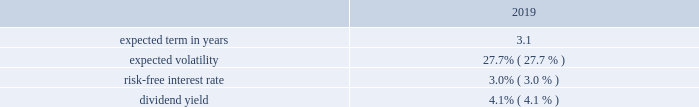Westrock company notes to consolidated financial statements 2014 ( continued ) our results of operations for the fiscal years ended september 30 , 2019 , 2018 and 2017 include share-based compensation expense of $ 64.2 million , $ 66.8 million and $ 60.9 million , respectively , including $ 2.9 million included in the gain on sale of hh&b in fiscal 2017 .
Share-based compensation expense in fiscal 2017 was reduced by $ 5.4 million for the rescission of shares granted to our ceo that were inadvertently granted in excess of plan limits in fiscal 2014 and 2015 .
The total income tax benefit in the results of operations in connection with share-based compensation was $ 16.3 million , $ 19.4 million and $ 22.5 million , for the fiscal years ended september 30 , 2019 , 2018 and 2017 , respectively .
Cash received from share-based payment arrangements for the fiscal years ended september 30 , 2019 , 2018 and 2017 was $ 61.5 million , $ 44.4 million and $ 59.2 million , respectively .
Equity awards issued in connection with acquisitions in connection with the kapstone acquisition , we replaced certain outstanding awards of restricted stock units granted under the kapstone long-term incentive plan with westrock stock options and restricted stock units .
No additional shares will be granted under the kapstone plan .
The kapstone equity awards were replaced with awards with identical terms utilizing an approximately 0.83 conversion factor as described in the merger agreement .
The acquisition consideration included approximately $ 70.8 million related to outstanding kapstone equity awards related to service prior to the effective date of the kapstone acquisition 2013 the balance related to service after the effective date will be expensed over the remaining service period of the awards .
As part of the kapstone acquisition , we issued 2665462 options that were valued at a weighted average fair value of $ 20.99 per share using the black-scholes option pricing model .
The weighted average significant assumptions used were: .
In connection with the mps acquisition , we replaced certain outstanding awards of restricted stock units granted under the mps long-term incentive plan with westrock restricted stock units .
No additional shares will be granted under the mps plan .
The mps equity awards were replaced with identical terms utilizing an approximately 0.33 conversion factor as described in the merger agreement .
As part of the mps acquisition , we granted 119373 awards of restricted stock units , which contain service conditions and were valued at $ 54.24 per share .
The acquisition consideration included approximately $ 1.9 million related to outstanding mps equity awards related to service prior to the effective date of the mps acquisition 2013 the balance related to service after the effective date will be expensed over the remaining service period of the awards .
Stock options and stock appreciation rights stock options granted under our plans generally have an exercise price equal to the closing market price on the date of the grant , generally vest in three years , in either one tranche or in approximately one-third increments , and have 10-year contractual terms .
However , a portion of our grants are subject to earlier expense recognition due to retirement eligibility rules .
Presently , other than circumstances such as death , disability and retirement , grants will include a provision requiring both a change of control and termination of employment to accelerate vesting .
At the date of grant , we estimate the fair value of stock options granted using a black-scholes option pricing model .
We use historical data to estimate option exercises and employee terminations in determining the expected term in years for stock options .
Expected volatility is calculated based on the historical volatility of our stock .
The risk-free interest rate is based on u.s .
Treasury securities in effect at the date of the grant of the stock options .
The dividend yield is estimated based on our historic annual dividend payments and current expectations for the future .
Other than in connection with replacement awards in connection with acquisitions , we did not grant any stock options in fiscal 2019 , 2018 and 2017. .
What was the value of the restricted stock units awarded in the mps acquisition? ( $ )? 
Computations: (119373 * 54.24)
Answer: 6474791.52. 